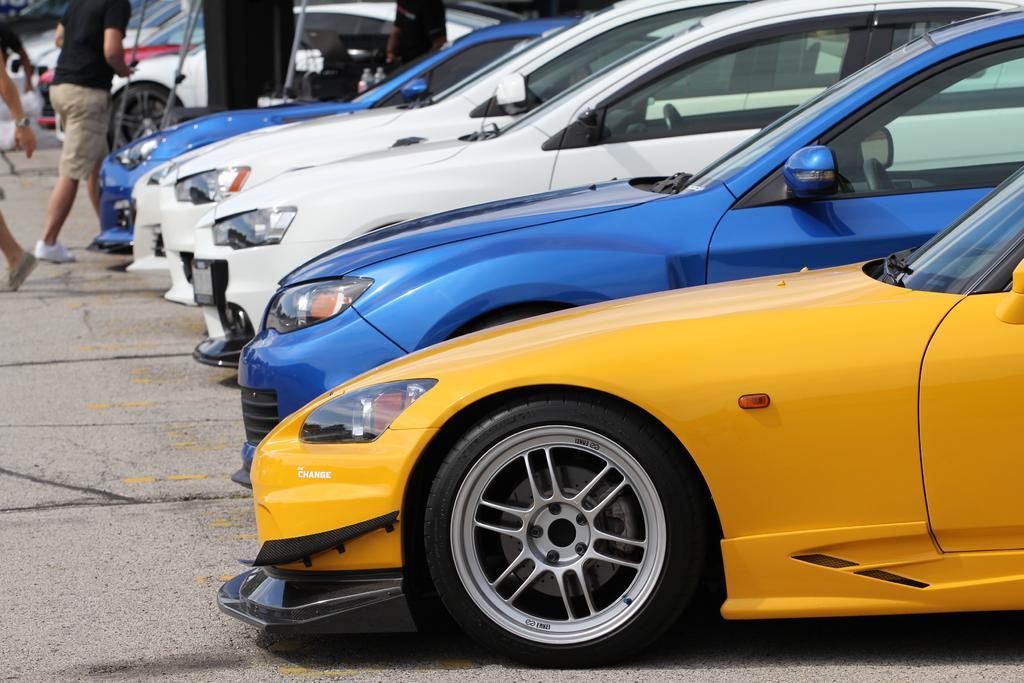Can you describe this image briefly? In this image there are cars in the center and in the background there are persons walking. 